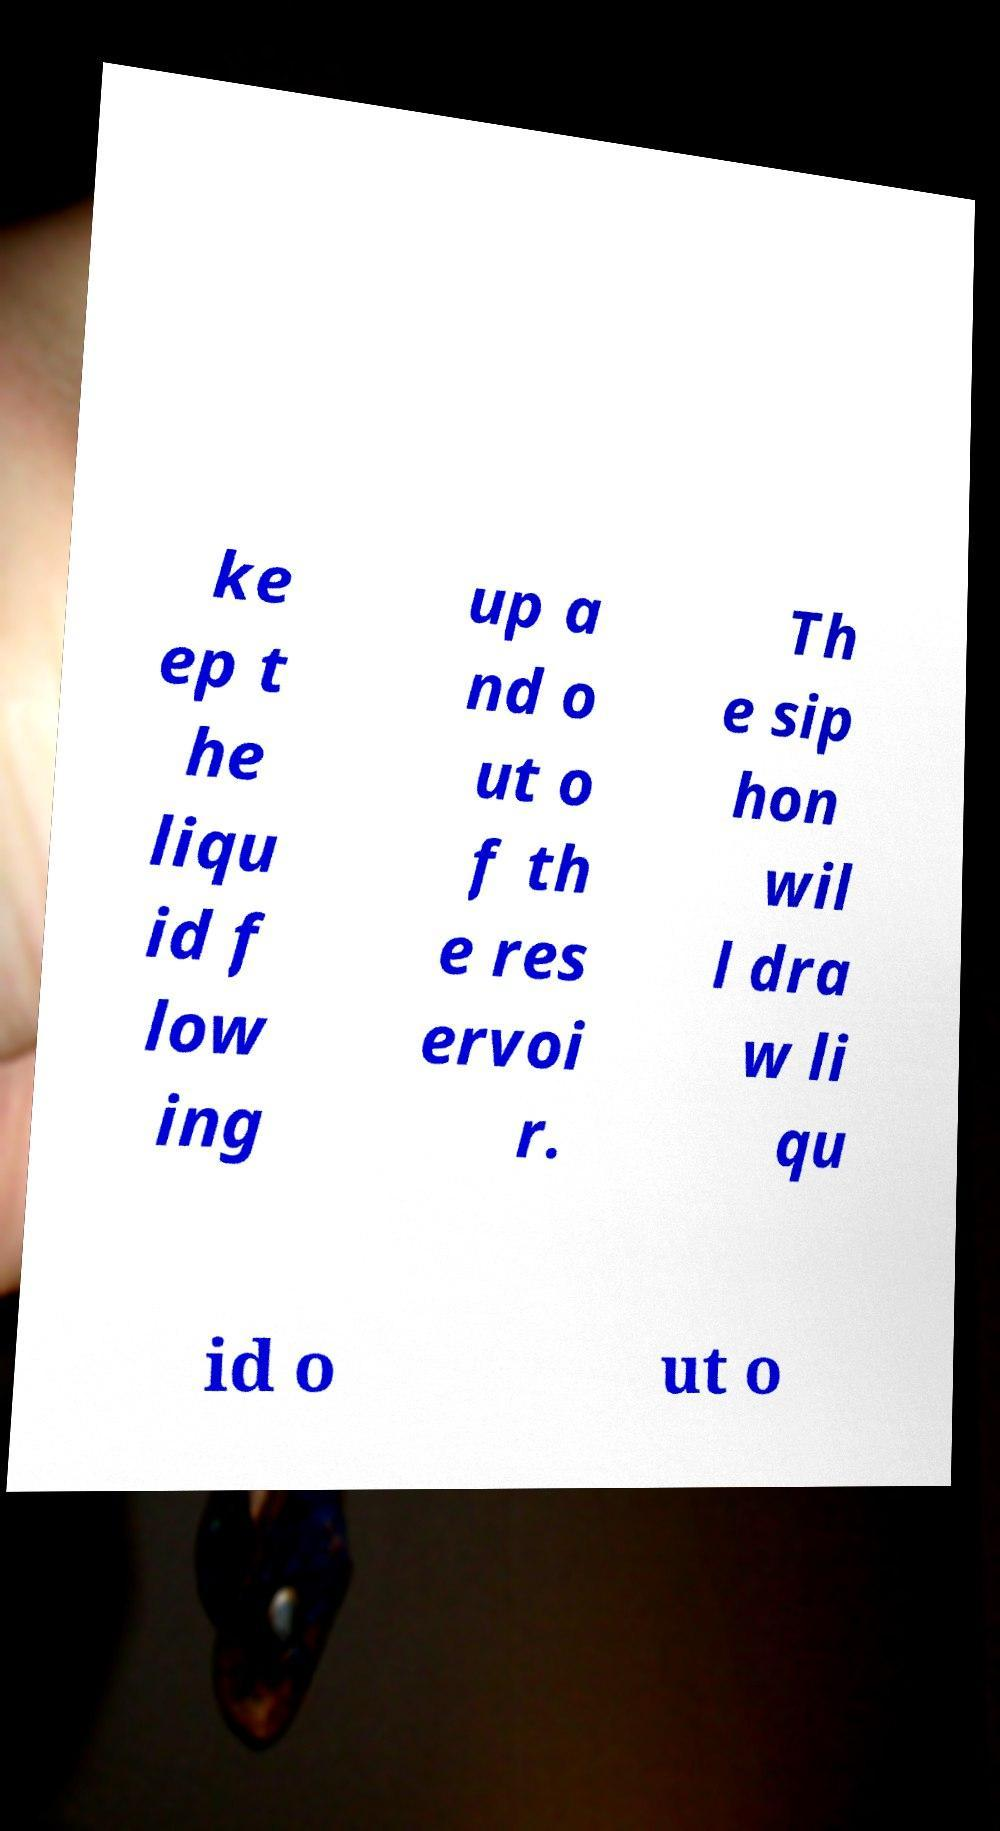There's text embedded in this image that I need extracted. Can you transcribe it verbatim? ke ep t he liqu id f low ing up a nd o ut o f th e res ervoi r. Th e sip hon wil l dra w li qu id o ut o 